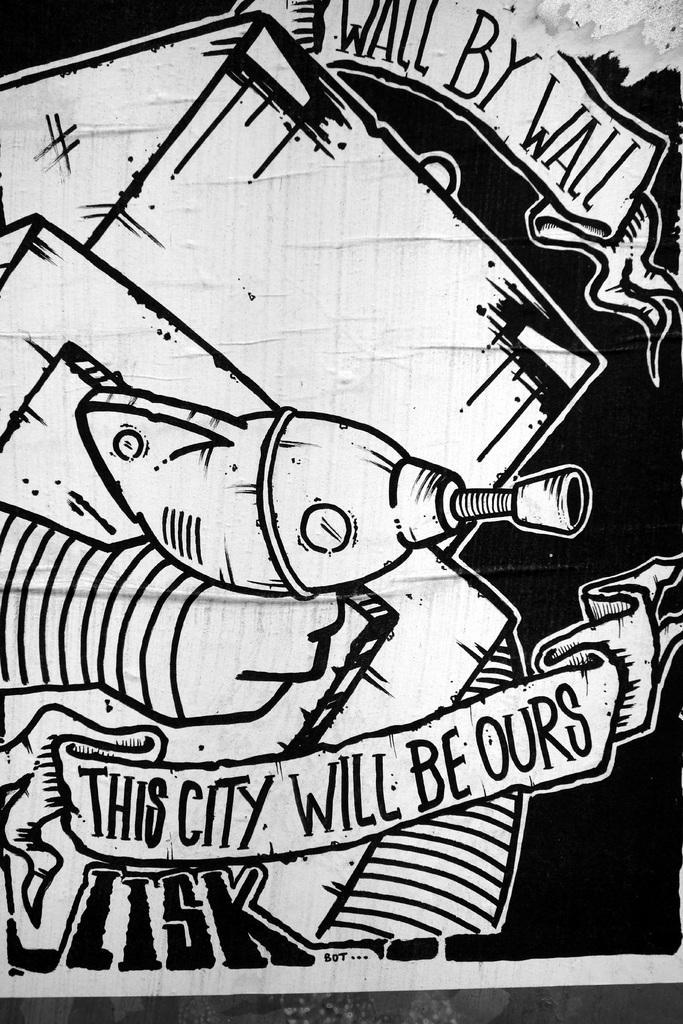Can you describe this image briefly? In this image we can see a sketch in which some text was written. 